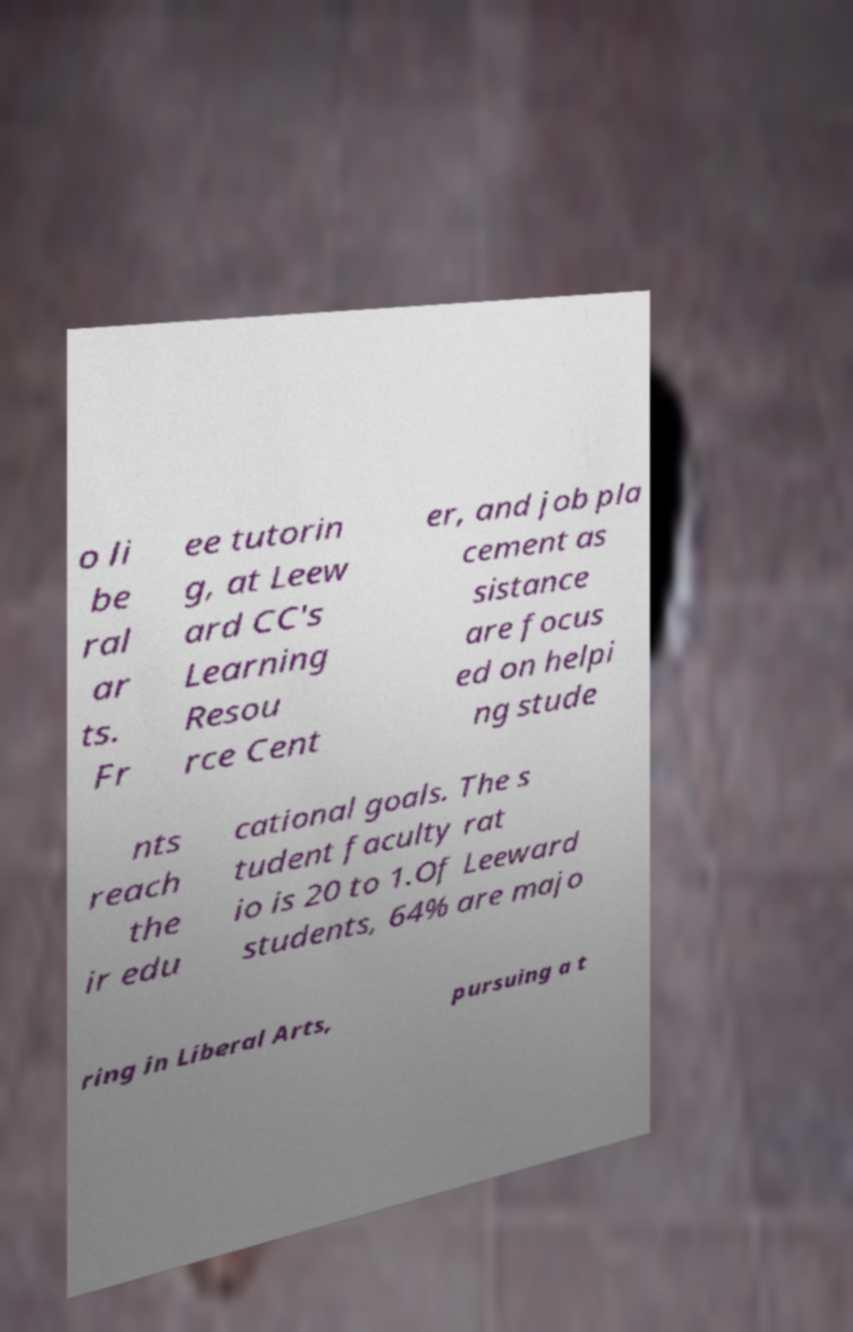Can you accurately transcribe the text from the provided image for me? o li be ral ar ts. Fr ee tutorin g, at Leew ard CC's Learning Resou rce Cent er, and job pla cement as sistance are focus ed on helpi ng stude nts reach the ir edu cational goals. The s tudent faculty rat io is 20 to 1.Of Leeward students, 64% are majo ring in Liberal Arts, pursuing a t 